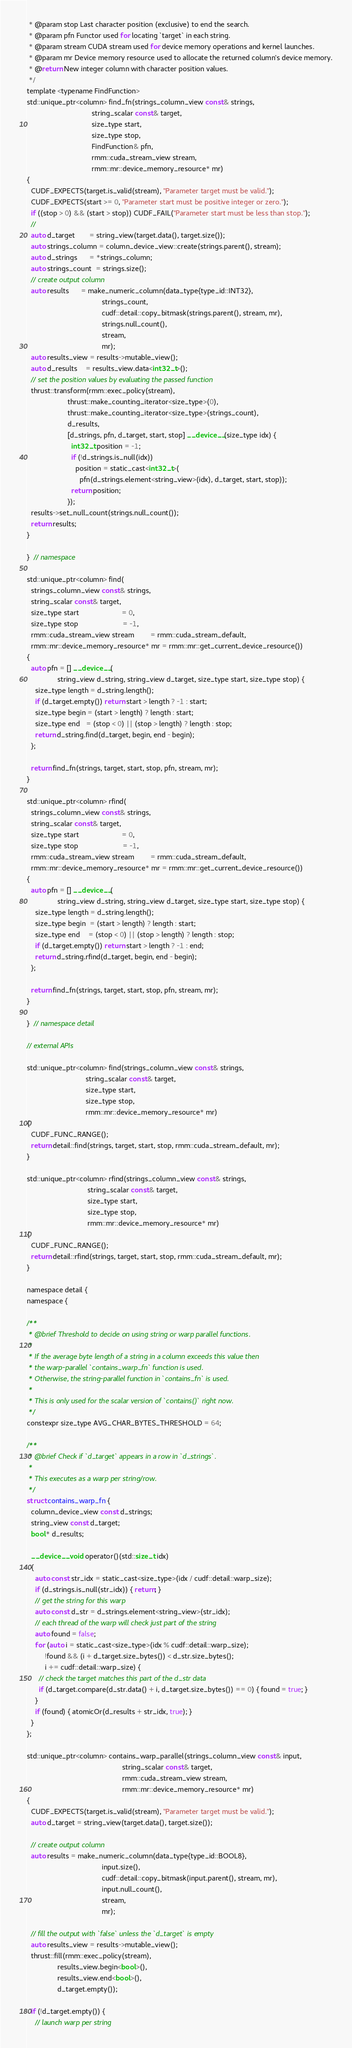Convert code to text. <code><loc_0><loc_0><loc_500><loc_500><_Cuda_> * @param stop Last character position (exclusive) to end the search.
 * @param pfn Functor used for locating `target` in each string.
 * @param stream CUDA stream used for device memory operations and kernel launches.
 * @param mr Device memory resource used to allocate the returned column's device memory.
 * @return New integer column with character position values.
 */
template <typename FindFunction>
std::unique_ptr<column> find_fn(strings_column_view const& strings,
                                string_scalar const& target,
                                size_type start,
                                size_type stop,
                                FindFunction& pfn,
                                rmm::cuda_stream_view stream,
                                rmm::mr::device_memory_resource* mr)
{
  CUDF_EXPECTS(target.is_valid(stream), "Parameter target must be valid.");
  CUDF_EXPECTS(start >= 0, "Parameter start must be positive integer or zero.");
  if ((stop > 0) && (start > stop)) CUDF_FAIL("Parameter start must be less than stop.");
  //
  auto d_target       = string_view(target.data(), target.size());
  auto strings_column = column_device_view::create(strings.parent(), stream);
  auto d_strings      = *strings_column;
  auto strings_count  = strings.size();
  // create output column
  auto results      = make_numeric_column(data_type{type_id::INT32},
                                     strings_count,
                                     cudf::detail::copy_bitmask(strings.parent(), stream, mr),
                                     strings.null_count(),
                                     stream,
                                     mr);
  auto results_view = results->mutable_view();
  auto d_results    = results_view.data<int32_t>();
  // set the position values by evaluating the passed function
  thrust::transform(rmm::exec_policy(stream),
                    thrust::make_counting_iterator<size_type>(0),
                    thrust::make_counting_iterator<size_type>(strings_count),
                    d_results,
                    [d_strings, pfn, d_target, start, stop] __device__(size_type idx) {
                      int32_t position = -1;
                      if (!d_strings.is_null(idx))
                        position = static_cast<int32_t>(
                          pfn(d_strings.element<string_view>(idx), d_target, start, stop));
                      return position;
                    });
  results->set_null_count(strings.null_count());
  return results;
}

}  // namespace

std::unique_ptr<column> find(
  strings_column_view const& strings,
  string_scalar const& target,
  size_type start                     = 0,
  size_type stop                      = -1,
  rmm::cuda_stream_view stream        = rmm::cuda_stream_default,
  rmm::mr::device_memory_resource* mr = rmm::mr::get_current_device_resource())
{
  auto pfn = [] __device__(
               string_view d_string, string_view d_target, size_type start, size_type stop) {
    size_type length = d_string.length();
    if (d_target.empty()) return start > length ? -1 : start;
    size_type begin = (start > length) ? length : start;
    size_type end   = (stop < 0) || (stop > length) ? length : stop;
    return d_string.find(d_target, begin, end - begin);
  };

  return find_fn(strings, target, start, stop, pfn, stream, mr);
}

std::unique_ptr<column> rfind(
  strings_column_view const& strings,
  string_scalar const& target,
  size_type start                     = 0,
  size_type stop                      = -1,
  rmm::cuda_stream_view stream        = rmm::cuda_stream_default,
  rmm::mr::device_memory_resource* mr = rmm::mr::get_current_device_resource())
{
  auto pfn = [] __device__(
               string_view d_string, string_view d_target, size_type start, size_type stop) {
    size_type length = d_string.length();
    size_type begin  = (start > length) ? length : start;
    size_type end    = (stop < 0) || (stop > length) ? length : stop;
    if (d_target.empty()) return start > length ? -1 : end;
    return d_string.rfind(d_target, begin, end - begin);
  };

  return find_fn(strings, target, start, stop, pfn, stream, mr);
}

}  // namespace detail

// external APIs

std::unique_ptr<column> find(strings_column_view const& strings,
                             string_scalar const& target,
                             size_type start,
                             size_type stop,
                             rmm::mr::device_memory_resource* mr)
{
  CUDF_FUNC_RANGE();
  return detail::find(strings, target, start, stop, rmm::cuda_stream_default, mr);
}

std::unique_ptr<column> rfind(strings_column_view const& strings,
                              string_scalar const& target,
                              size_type start,
                              size_type stop,
                              rmm::mr::device_memory_resource* mr)
{
  CUDF_FUNC_RANGE();
  return detail::rfind(strings, target, start, stop, rmm::cuda_stream_default, mr);
}

namespace detail {
namespace {

/**
 * @brief Threshold to decide on using string or warp parallel functions.
 *
 * If the average byte length of a string in a column exceeds this value then
 * the warp-parallel `contains_warp_fn` function is used.
 * Otherwise, the string-parallel function in `contains_fn` is used.
 *
 * This is only used for the scalar version of `contains()` right now.
 */
constexpr size_type AVG_CHAR_BYTES_THRESHOLD = 64;

/**
 * @brief Check if `d_target` appears in a row in `d_strings`.
 *
 * This executes as a warp per string/row.
 */
struct contains_warp_fn {
  column_device_view const d_strings;
  string_view const d_target;
  bool* d_results;

  __device__ void operator()(std::size_t idx)
  {
    auto const str_idx = static_cast<size_type>(idx / cudf::detail::warp_size);
    if (d_strings.is_null(str_idx)) { return; }
    // get the string for this warp
    auto const d_str = d_strings.element<string_view>(str_idx);
    // each thread of the warp will check just part of the string
    auto found = false;
    for (auto i = static_cast<size_type>(idx % cudf::detail::warp_size);
         !found && (i + d_target.size_bytes()) < d_str.size_bytes();
         i += cudf::detail::warp_size) {
      // check the target matches this part of the d_str data
      if (d_target.compare(d_str.data() + i, d_target.size_bytes()) == 0) { found = true; }
    }
    if (found) { atomicOr(d_results + str_idx, true); }
  }
};

std::unique_ptr<column> contains_warp_parallel(strings_column_view const& input,
                                               string_scalar const& target,
                                               rmm::cuda_stream_view stream,
                                               rmm::mr::device_memory_resource* mr)
{
  CUDF_EXPECTS(target.is_valid(stream), "Parameter target must be valid.");
  auto d_target = string_view(target.data(), target.size());

  // create output column
  auto results = make_numeric_column(data_type{type_id::BOOL8},
                                     input.size(),
                                     cudf::detail::copy_bitmask(input.parent(), stream, mr),
                                     input.null_count(),
                                     stream,
                                     mr);

  // fill the output with `false` unless the `d_target` is empty
  auto results_view = results->mutable_view();
  thrust::fill(rmm::exec_policy(stream),
               results_view.begin<bool>(),
               results_view.end<bool>(),
               d_target.empty());

  if (!d_target.empty()) {
    // launch warp per string</code> 